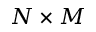<formula> <loc_0><loc_0><loc_500><loc_500>N \times M</formula> 